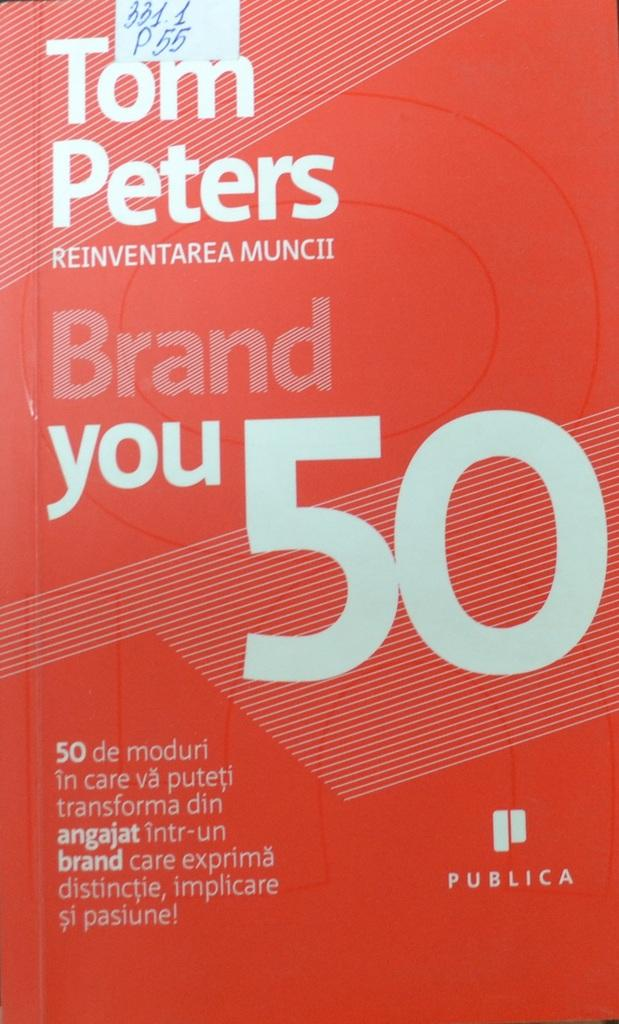<image>
Offer a succinct explanation of the picture presented. A book written by Tom Peters with a red cover. 